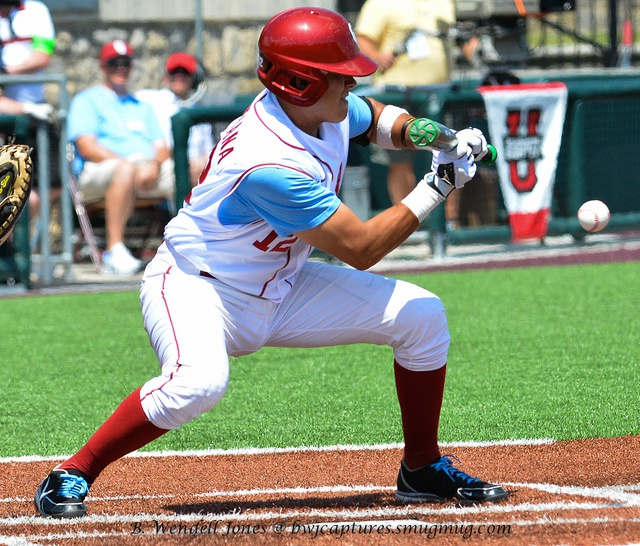Describe the objects in this image and their specific colors. I can see people in black, white, darkgray, and maroon tones, people in black, white, gray, darkgray, and lightblue tones, people in black, ivory, khaki, and tan tones, people in black, white, darkgray, and gray tones, and people in black, white, gray, and salmon tones in this image. 